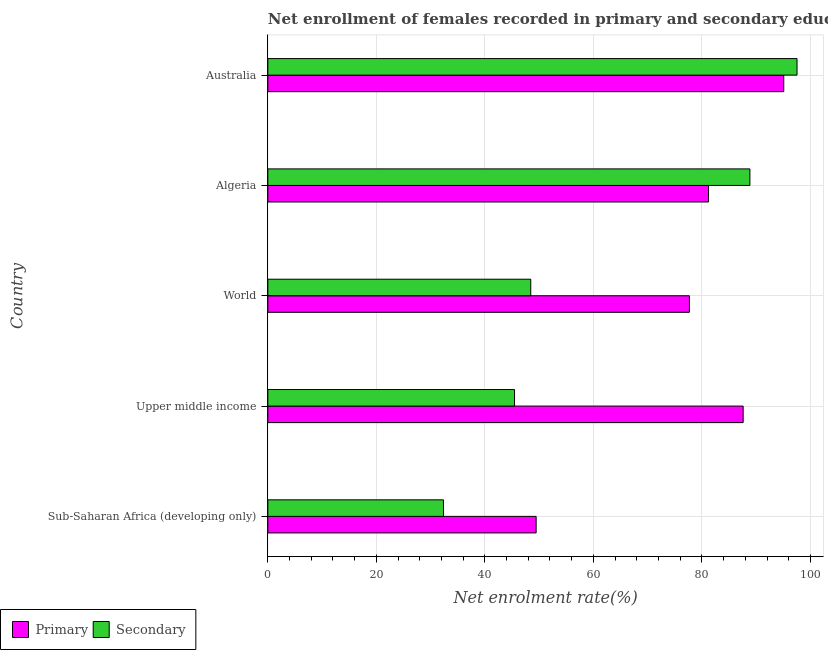How many groups of bars are there?
Your answer should be compact. 5. Are the number of bars on each tick of the Y-axis equal?
Offer a very short reply. Yes. How many bars are there on the 4th tick from the bottom?
Provide a succinct answer. 2. What is the label of the 1st group of bars from the top?
Your response must be concise. Australia. What is the enrollment rate in secondary education in Australia?
Your answer should be very brief. 97.53. Across all countries, what is the maximum enrollment rate in primary education?
Provide a short and direct response. 95.08. Across all countries, what is the minimum enrollment rate in primary education?
Give a very brief answer. 49.45. In which country was the enrollment rate in secondary education minimum?
Your answer should be compact. Sub-Saharan Africa (developing only). What is the total enrollment rate in secondary education in the graph?
Your answer should be very brief. 312.67. What is the difference between the enrollment rate in secondary education in Australia and that in World?
Your answer should be very brief. 49.07. What is the difference between the enrollment rate in secondary education in World and the enrollment rate in primary education in Sub-Saharan Africa (developing only)?
Offer a very short reply. -0.99. What is the average enrollment rate in primary education per country?
Ensure brevity in your answer.  78.21. What is the difference between the enrollment rate in secondary education and enrollment rate in primary education in Australia?
Your answer should be compact. 2.45. What is the ratio of the enrollment rate in secondary education in Australia to that in World?
Provide a short and direct response. 2.01. Is the enrollment rate in secondary education in Upper middle income less than that in World?
Make the answer very short. Yes. What is the difference between the highest and the second highest enrollment rate in secondary education?
Your answer should be compact. 8.69. What is the difference between the highest and the lowest enrollment rate in secondary education?
Provide a short and direct response. 65.16. What does the 2nd bar from the top in Upper middle income represents?
Your response must be concise. Primary. What does the 2nd bar from the bottom in Upper middle income represents?
Give a very brief answer. Secondary. How many bars are there?
Offer a terse response. 10. Are all the bars in the graph horizontal?
Keep it short and to the point. Yes. How many countries are there in the graph?
Offer a very short reply. 5. Where does the legend appear in the graph?
Ensure brevity in your answer.  Bottom left. How are the legend labels stacked?
Provide a short and direct response. Horizontal. What is the title of the graph?
Keep it short and to the point. Net enrollment of females recorded in primary and secondary education in year 1996. Does "Methane" appear as one of the legend labels in the graph?
Keep it short and to the point. No. What is the label or title of the X-axis?
Your answer should be very brief. Net enrolment rate(%). What is the Net enrolment rate(%) of Primary in Sub-Saharan Africa (developing only)?
Keep it short and to the point. 49.45. What is the Net enrolment rate(%) of Secondary in Sub-Saharan Africa (developing only)?
Provide a short and direct response. 32.37. What is the Net enrolment rate(%) of Primary in Upper middle income?
Your response must be concise. 87.6. What is the Net enrolment rate(%) of Secondary in Upper middle income?
Your response must be concise. 45.46. What is the Net enrolment rate(%) in Primary in World?
Offer a terse response. 77.7. What is the Net enrolment rate(%) in Secondary in World?
Your answer should be very brief. 48.46. What is the Net enrolment rate(%) of Primary in Algeria?
Make the answer very short. 81.22. What is the Net enrolment rate(%) of Secondary in Algeria?
Make the answer very short. 88.85. What is the Net enrolment rate(%) in Primary in Australia?
Your answer should be very brief. 95.08. What is the Net enrolment rate(%) in Secondary in Australia?
Your answer should be very brief. 97.53. Across all countries, what is the maximum Net enrolment rate(%) in Primary?
Your answer should be very brief. 95.08. Across all countries, what is the maximum Net enrolment rate(%) in Secondary?
Make the answer very short. 97.53. Across all countries, what is the minimum Net enrolment rate(%) of Primary?
Your answer should be very brief. 49.45. Across all countries, what is the minimum Net enrolment rate(%) in Secondary?
Give a very brief answer. 32.37. What is the total Net enrolment rate(%) in Primary in the graph?
Your answer should be very brief. 391.05. What is the total Net enrolment rate(%) in Secondary in the graph?
Ensure brevity in your answer.  312.67. What is the difference between the Net enrolment rate(%) in Primary in Sub-Saharan Africa (developing only) and that in Upper middle income?
Your answer should be very brief. -38.16. What is the difference between the Net enrolment rate(%) of Secondary in Sub-Saharan Africa (developing only) and that in Upper middle income?
Your answer should be very brief. -13.09. What is the difference between the Net enrolment rate(%) in Primary in Sub-Saharan Africa (developing only) and that in World?
Your response must be concise. -28.25. What is the difference between the Net enrolment rate(%) of Secondary in Sub-Saharan Africa (developing only) and that in World?
Make the answer very short. -16.08. What is the difference between the Net enrolment rate(%) of Primary in Sub-Saharan Africa (developing only) and that in Algeria?
Your answer should be very brief. -31.78. What is the difference between the Net enrolment rate(%) in Secondary in Sub-Saharan Africa (developing only) and that in Algeria?
Give a very brief answer. -56.47. What is the difference between the Net enrolment rate(%) in Primary in Sub-Saharan Africa (developing only) and that in Australia?
Offer a very short reply. -45.64. What is the difference between the Net enrolment rate(%) in Secondary in Sub-Saharan Africa (developing only) and that in Australia?
Provide a succinct answer. -65.16. What is the difference between the Net enrolment rate(%) of Primary in Upper middle income and that in World?
Give a very brief answer. 9.91. What is the difference between the Net enrolment rate(%) in Secondary in Upper middle income and that in World?
Provide a succinct answer. -2.99. What is the difference between the Net enrolment rate(%) of Primary in Upper middle income and that in Algeria?
Offer a terse response. 6.38. What is the difference between the Net enrolment rate(%) of Secondary in Upper middle income and that in Algeria?
Offer a very short reply. -43.38. What is the difference between the Net enrolment rate(%) in Primary in Upper middle income and that in Australia?
Your response must be concise. -7.48. What is the difference between the Net enrolment rate(%) in Secondary in Upper middle income and that in Australia?
Ensure brevity in your answer.  -52.07. What is the difference between the Net enrolment rate(%) of Primary in World and that in Algeria?
Your response must be concise. -3.53. What is the difference between the Net enrolment rate(%) in Secondary in World and that in Algeria?
Ensure brevity in your answer.  -40.39. What is the difference between the Net enrolment rate(%) of Primary in World and that in Australia?
Ensure brevity in your answer.  -17.39. What is the difference between the Net enrolment rate(%) in Secondary in World and that in Australia?
Give a very brief answer. -49.07. What is the difference between the Net enrolment rate(%) of Primary in Algeria and that in Australia?
Your answer should be very brief. -13.86. What is the difference between the Net enrolment rate(%) of Secondary in Algeria and that in Australia?
Your answer should be very brief. -8.69. What is the difference between the Net enrolment rate(%) in Primary in Sub-Saharan Africa (developing only) and the Net enrolment rate(%) in Secondary in Upper middle income?
Your answer should be very brief. 3.98. What is the difference between the Net enrolment rate(%) of Primary in Sub-Saharan Africa (developing only) and the Net enrolment rate(%) of Secondary in World?
Keep it short and to the point. 0.99. What is the difference between the Net enrolment rate(%) in Primary in Sub-Saharan Africa (developing only) and the Net enrolment rate(%) in Secondary in Algeria?
Your answer should be very brief. -39.4. What is the difference between the Net enrolment rate(%) in Primary in Sub-Saharan Africa (developing only) and the Net enrolment rate(%) in Secondary in Australia?
Your answer should be compact. -48.08. What is the difference between the Net enrolment rate(%) in Primary in Upper middle income and the Net enrolment rate(%) in Secondary in World?
Ensure brevity in your answer.  39.15. What is the difference between the Net enrolment rate(%) of Primary in Upper middle income and the Net enrolment rate(%) of Secondary in Algeria?
Ensure brevity in your answer.  -1.24. What is the difference between the Net enrolment rate(%) in Primary in Upper middle income and the Net enrolment rate(%) in Secondary in Australia?
Make the answer very short. -9.93. What is the difference between the Net enrolment rate(%) of Primary in World and the Net enrolment rate(%) of Secondary in Algeria?
Your answer should be very brief. -11.15. What is the difference between the Net enrolment rate(%) of Primary in World and the Net enrolment rate(%) of Secondary in Australia?
Your answer should be compact. -19.83. What is the difference between the Net enrolment rate(%) in Primary in Algeria and the Net enrolment rate(%) in Secondary in Australia?
Offer a very short reply. -16.31. What is the average Net enrolment rate(%) in Primary per country?
Provide a short and direct response. 78.21. What is the average Net enrolment rate(%) of Secondary per country?
Keep it short and to the point. 62.53. What is the difference between the Net enrolment rate(%) in Primary and Net enrolment rate(%) in Secondary in Sub-Saharan Africa (developing only)?
Your answer should be very brief. 17.07. What is the difference between the Net enrolment rate(%) of Primary and Net enrolment rate(%) of Secondary in Upper middle income?
Your response must be concise. 42.14. What is the difference between the Net enrolment rate(%) of Primary and Net enrolment rate(%) of Secondary in World?
Ensure brevity in your answer.  29.24. What is the difference between the Net enrolment rate(%) in Primary and Net enrolment rate(%) in Secondary in Algeria?
Provide a succinct answer. -7.62. What is the difference between the Net enrolment rate(%) of Primary and Net enrolment rate(%) of Secondary in Australia?
Ensure brevity in your answer.  -2.45. What is the ratio of the Net enrolment rate(%) of Primary in Sub-Saharan Africa (developing only) to that in Upper middle income?
Your answer should be compact. 0.56. What is the ratio of the Net enrolment rate(%) in Secondary in Sub-Saharan Africa (developing only) to that in Upper middle income?
Provide a succinct answer. 0.71. What is the ratio of the Net enrolment rate(%) of Primary in Sub-Saharan Africa (developing only) to that in World?
Your answer should be compact. 0.64. What is the ratio of the Net enrolment rate(%) of Secondary in Sub-Saharan Africa (developing only) to that in World?
Ensure brevity in your answer.  0.67. What is the ratio of the Net enrolment rate(%) in Primary in Sub-Saharan Africa (developing only) to that in Algeria?
Provide a short and direct response. 0.61. What is the ratio of the Net enrolment rate(%) in Secondary in Sub-Saharan Africa (developing only) to that in Algeria?
Your response must be concise. 0.36. What is the ratio of the Net enrolment rate(%) of Primary in Sub-Saharan Africa (developing only) to that in Australia?
Your answer should be compact. 0.52. What is the ratio of the Net enrolment rate(%) of Secondary in Sub-Saharan Africa (developing only) to that in Australia?
Give a very brief answer. 0.33. What is the ratio of the Net enrolment rate(%) in Primary in Upper middle income to that in World?
Offer a very short reply. 1.13. What is the ratio of the Net enrolment rate(%) of Secondary in Upper middle income to that in World?
Your answer should be very brief. 0.94. What is the ratio of the Net enrolment rate(%) of Primary in Upper middle income to that in Algeria?
Make the answer very short. 1.08. What is the ratio of the Net enrolment rate(%) in Secondary in Upper middle income to that in Algeria?
Ensure brevity in your answer.  0.51. What is the ratio of the Net enrolment rate(%) in Primary in Upper middle income to that in Australia?
Offer a very short reply. 0.92. What is the ratio of the Net enrolment rate(%) of Secondary in Upper middle income to that in Australia?
Give a very brief answer. 0.47. What is the ratio of the Net enrolment rate(%) of Primary in World to that in Algeria?
Provide a succinct answer. 0.96. What is the ratio of the Net enrolment rate(%) in Secondary in World to that in Algeria?
Make the answer very short. 0.55. What is the ratio of the Net enrolment rate(%) of Primary in World to that in Australia?
Your response must be concise. 0.82. What is the ratio of the Net enrolment rate(%) of Secondary in World to that in Australia?
Your response must be concise. 0.5. What is the ratio of the Net enrolment rate(%) of Primary in Algeria to that in Australia?
Ensure brevity in your answer.  0.85. What is the ratio of the Net enrolment rate(%) of Secondary in Algeria to that in Australia?
Provide a succinct answer. 0.91. What is the difference between the highest and the second highest Net enrolment rate(%) in Primary?
Provide a short and direct response. 7.48. What is the difference between the highest and the second highest Net enrolment rate(%) in Secondary?
Your response must be concise. 8.69. What is the difference between the highest and the lowest Net enrolment rate(%) of Primary?
Ensure brevity in your answer.  45.64. What is the difference between the highest and the lowest Net enrolment rate(%) of Secondary?
Provide a succinct answer. 65.16. 